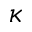<formula> <loc_0><loc_0><loc_500><loc_500>\kappa</formula> 